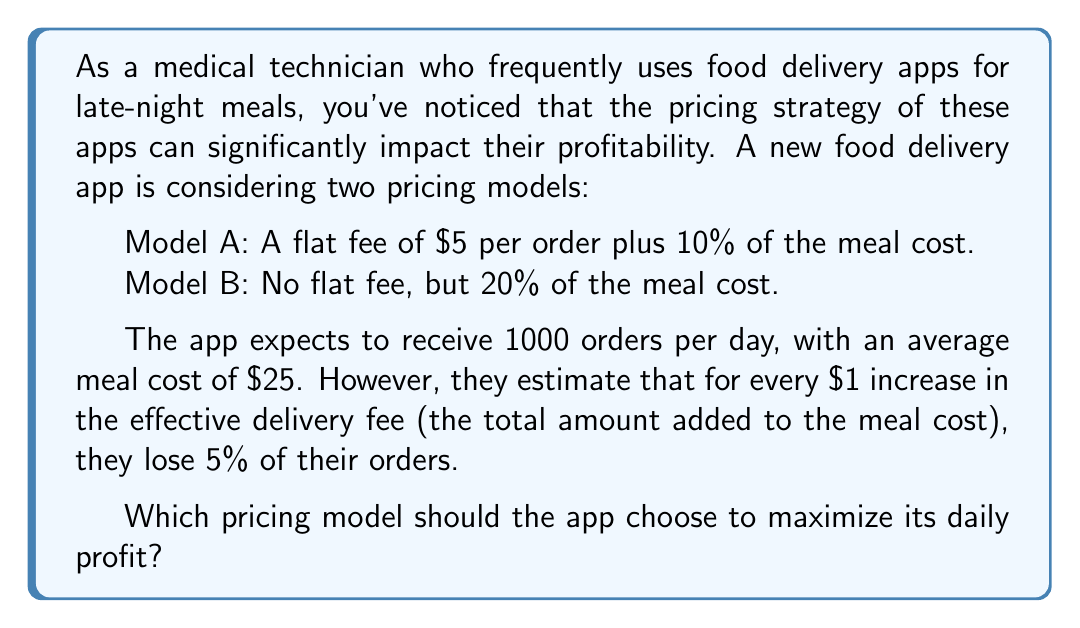Teach me how to tackle this problem. Let's approach this step-by-step:

1) First, let's calculate the effective delivery fee for each model:

   Model A: $5 + (10% of $25) = $5 + $2.50 = $7.50
   Model B: 20% of $25 = $5

2) Model A's effective fee is $2.50 higher than Model B's. This means Model A would lose 12.5% of orders compared to Model B (2.5 * 5% = 12.5%).

3) Let's calculate the number of orders for each model:

   Model B: 1000 orders (baseline)
   Model A: 1000 * (1 - 0.125) = 875 orders

4) Now, let's calculate the profit per order for each model:

   Model A: $5 + (0.10 * $25) = $7.50 per order
   Model B: 0.20 * $25 = $5 per order

5) Finally, let's calculate the total daily profit for each model:

   Model A: 875 * $7.50 = $6,562.50
   Model B: 1000 * $5 = $5,000

Therefore, despite losing some orders due to the higher effective fee, Model A generates more profit and should be chosen to maximize daily profit.
Answer: The app should choose Model A (flat fee of $5 plus 10% of meal cost) to maximize its daily profit, which would be $6,562.50. 